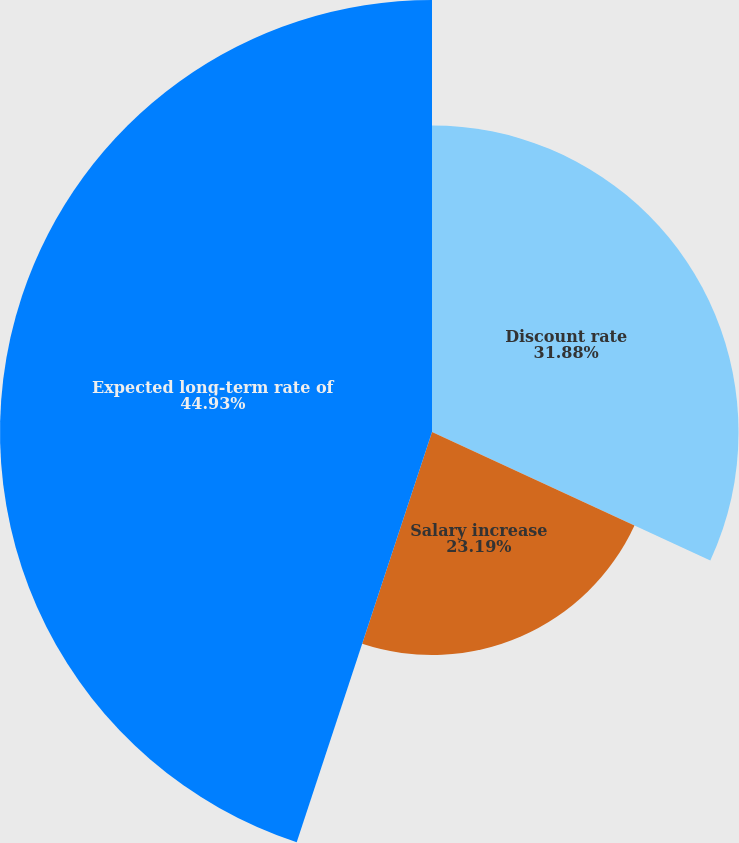Convert chart to OTSL. <chart><loc_0><loc_0><loc_500><loc_500><pie_chart><fcel>Discount rate<fcel>Salary increase<fcel>Expected long-term rate of<nl><fcel>31.88%<fcel>23.19%<fcel>44.93%<nl></chart> 